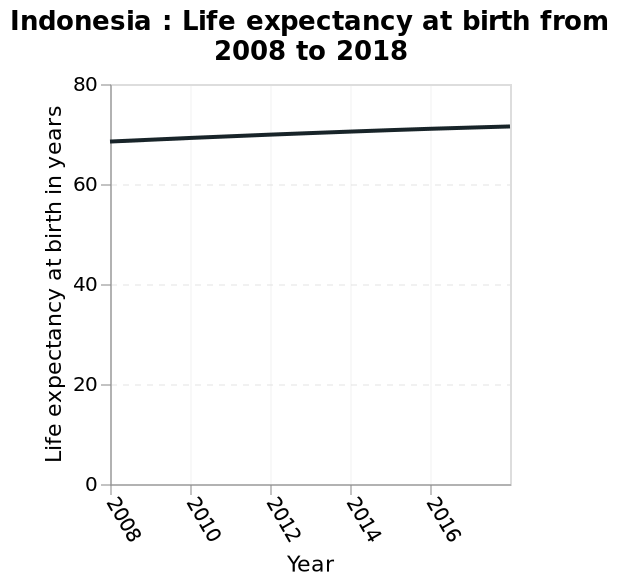<image>
What is the y-axis of the line chart measuring? The y-axis of the line chart measures life expectancy at birth in years. 